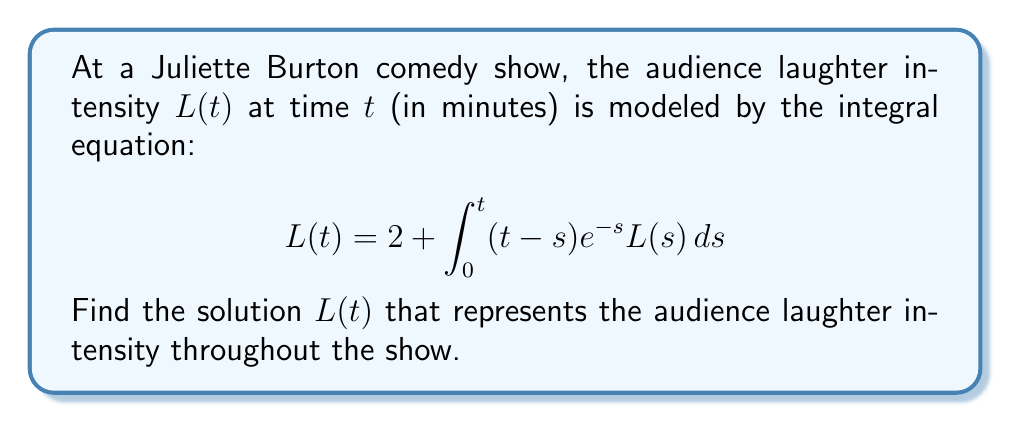Teach me how to tackle this problem. To solve this integral equation, we'll use the Laplace transform method:

1) Let's denote the Laplace transform of $L(t)$ as $\mathcal{L}\{L(t)\} = \bar{L}(p)$.

2) Take the Laplace transform of both sides of the equation:
   $$\mathcal{L}\{L(t)\} = \mathcal{L}\{2\} + \mathcal{L}\{\int_0^t (t-s)e^{-s}L(s)ds\}$$

3) Using Laplace transform properties:
   $$\bar{L}(p) = \frac{2}{p} + \frac{1}{p(p+1)}\bar{L}(p)$$

4) Rearrange the equation:
   $$\bar{L}(p) - \frac{1}{p(p+1)}\bar{L}(p) = \frac{2}{p}$$
   $$\bar{L}(p)\left(1 - \frac{1}{p(p+1)}\right) = \frac{2}{p}$$

5) Simplify:
   $$\bar{L}(p)\left(\frac{p^2+p-1}{p(p+1)}\right) = \frac{2}{p}$$
   $$\bar{L}(p) = \frac{2p(p+1)}{p^2+p-1}$$

6) Decompose into partial fractions:
   $$\bar{L}(p) = \frac{2(p+1)}{p-\frac{\sqrt{5}-1}{2}} + \frac{2(p+1)}{p+\frac{\sqrt{5}+1}{2}}$$

7) Take the inverse Laplace transform:
   $$L(t) = 2e^{\frac{\sqrt{5}-1}{2}t} + 2e^{-\frac{\sqrt{5}+1}{2}t}$$

This is the solution representing the audience laughter intensity over time.
Answer: $L(t) = 2e^{\frac{\sqrt{5}-1}{2}t} + 2e^{-\frac{\sqrt{5}+1}{2}t}$ 